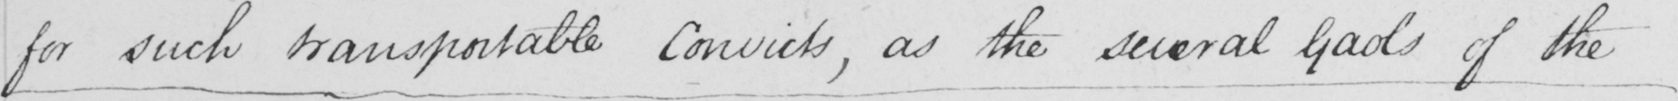Transcribe the text shown in this historical manuscript line. for such transportable Convicts , as the several gaols of the 